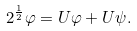<formula> <loc_0><loc_0><loc_500><loc_500>2 ^ { \frac { 1 } { 2 } } \varphi = U \varphi + U \psi .</formula> 